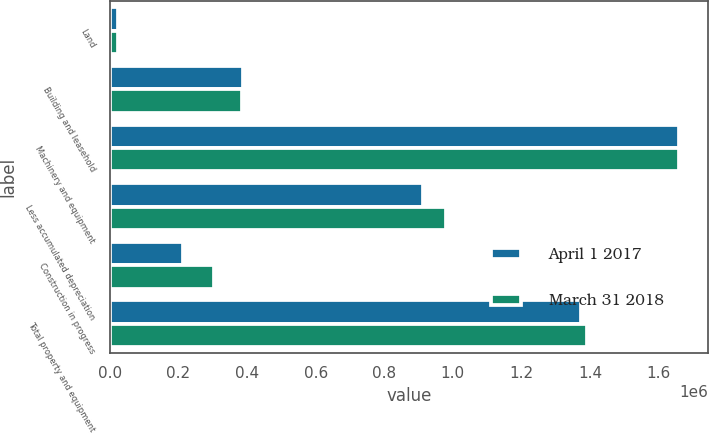Convert chart. <chart><loc_0><loc_0><loc_500><loc_500><stacked_bar_chart><ecel><fcel>Land<fcel>Building and leasehold<fcel>Machinery and equipment<fcel>Less accumulated depreciation<fcel>Construction in progress<fcel>Total property and equipment<nl><fcel>April 1 2017<fcel>23778<fcel>389234<fcel>1.66014e+06<fcel>911910<fcel>212872<fcel>1.37411e+06<nl><fcel>March 31 2018<fcel>25025<fcel>384784<fcel>1.6594e+06<fcel>981328<fcel>304047<fcel>1.39193e+06<nl></chart> 